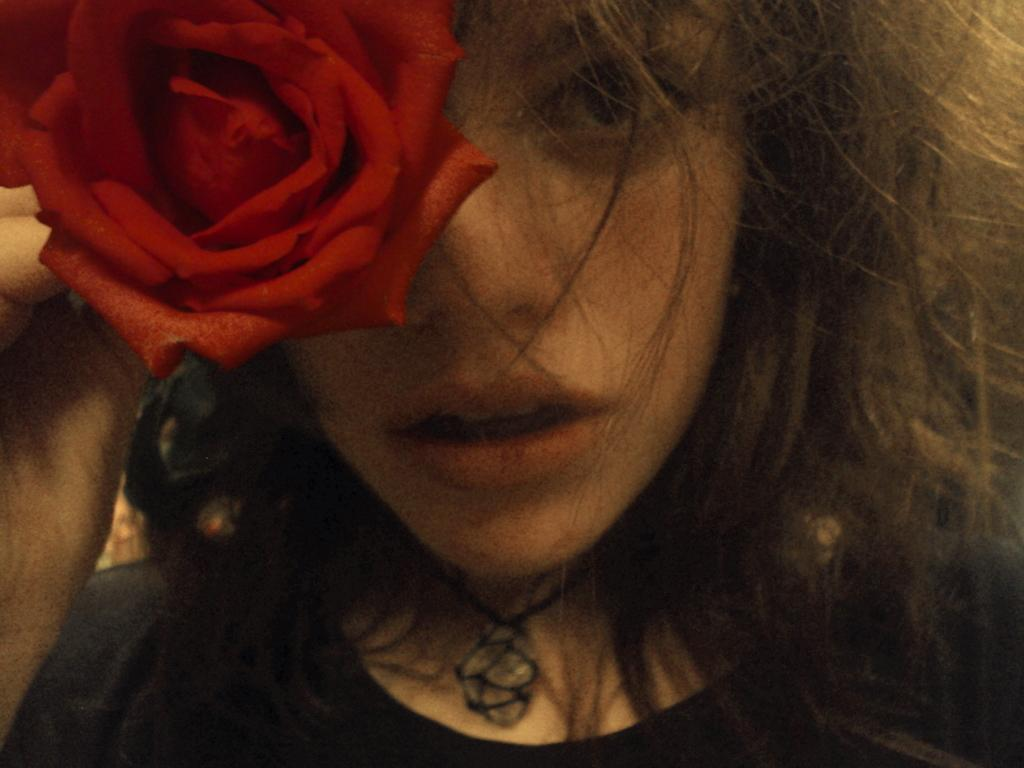What is the main subject in the foreground of the image? There is a woman in the foreground of the image. What is the woman holding in the image? The woman is holding a rose flower. How many copies of the rose flower can be seen in the image? There is only one rose flower visible in the image, so there are no copies. 